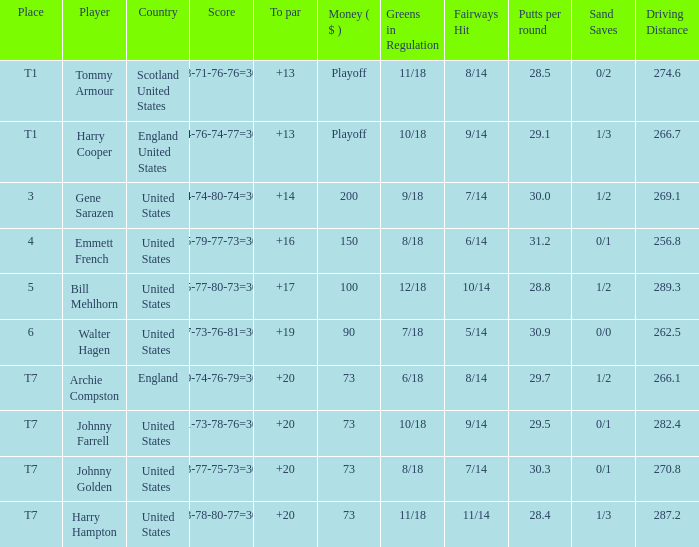What is the score for the United States when Harry Hampton is the player and the money is $73? 73-78-80-77=308. 